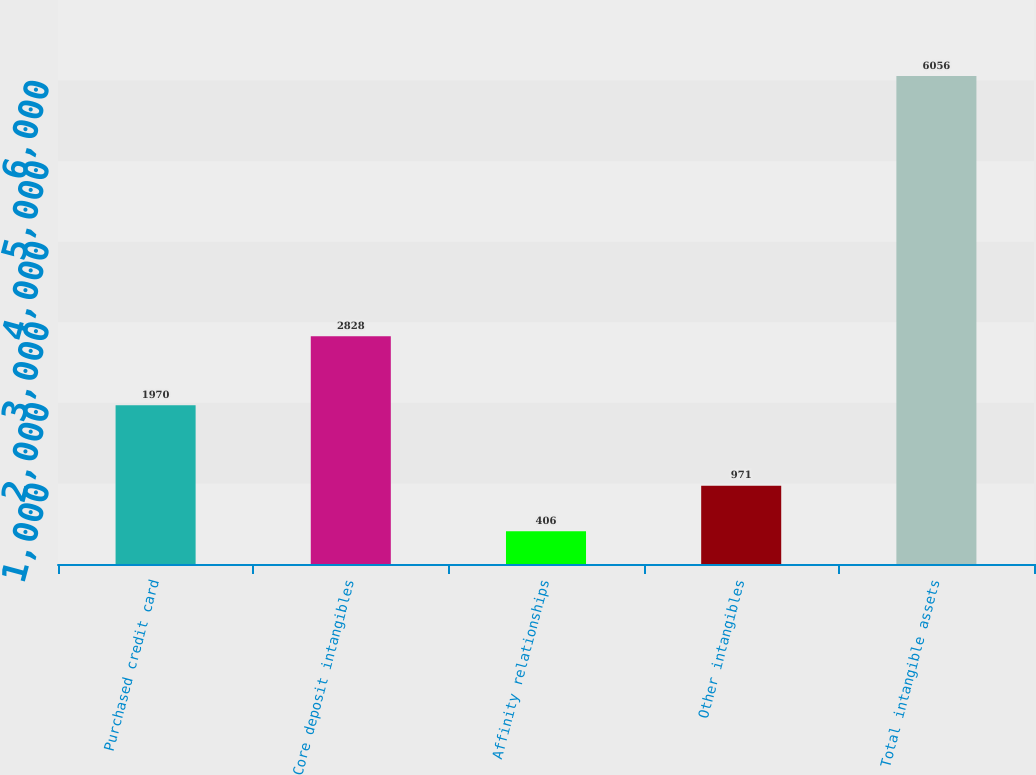<chart> <loc_0><loc_0><loc_500><loc_500><bar_chart><fcel>Purchased credit card<fcel>Core deposit intangibles<fcel>Affinity relationships<fcel>Other intangibles<fcel>Total intangible assets<nl><fcel>1970<fcel>2828<fcel>406<fcel>971<fcel>6056<nl></chart> 